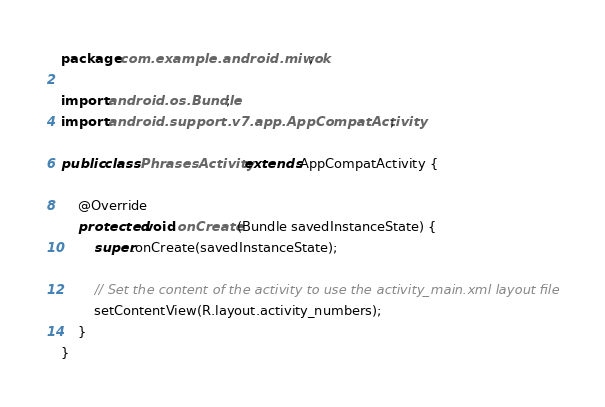<code> <loc_0><loc_0><loc_500><loc_500><_Java_>package com.example.android.miwok;

import android.os.Bundle;
import android.support.v7.app.AppCompatActivity;

public class PhrasesActivity extends AppCompatActivity {

    @Override
    protected void onCreate(Bundle savedInstanceState) {
        super.onCreate(savedInstanceState);

        // Set the content of the activity to use the activity_main.xml layout file
        setContentView(R.layout.activity_numbers);
    }
}
</code> 